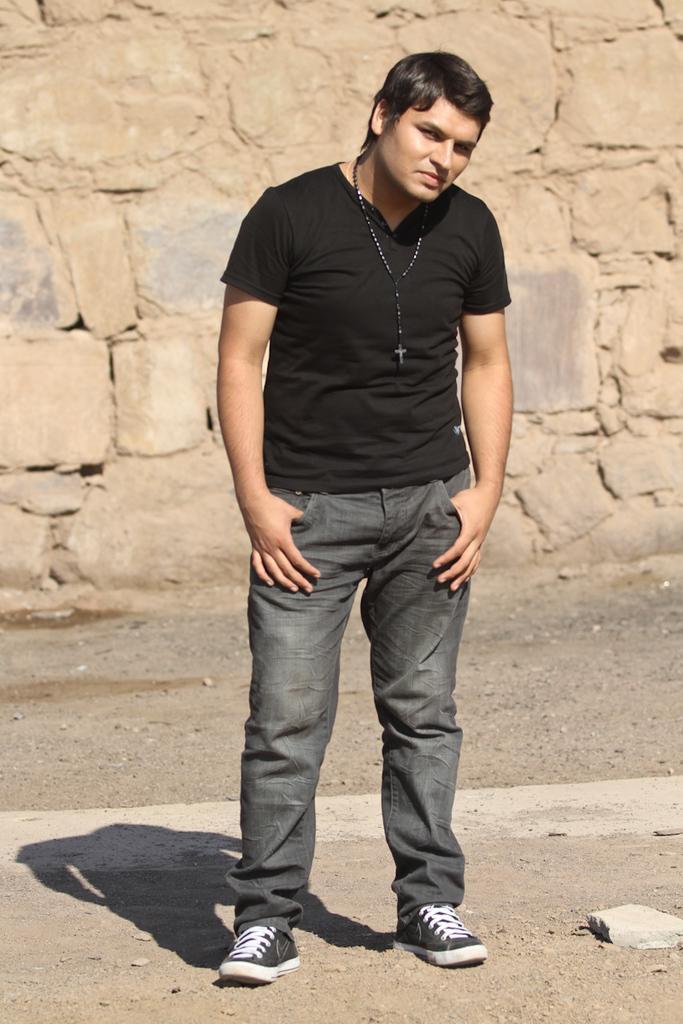In one or two sentences, can you explain what this image depicts? In this image we can see a person wearing a rosary. In the back there is a wall. 